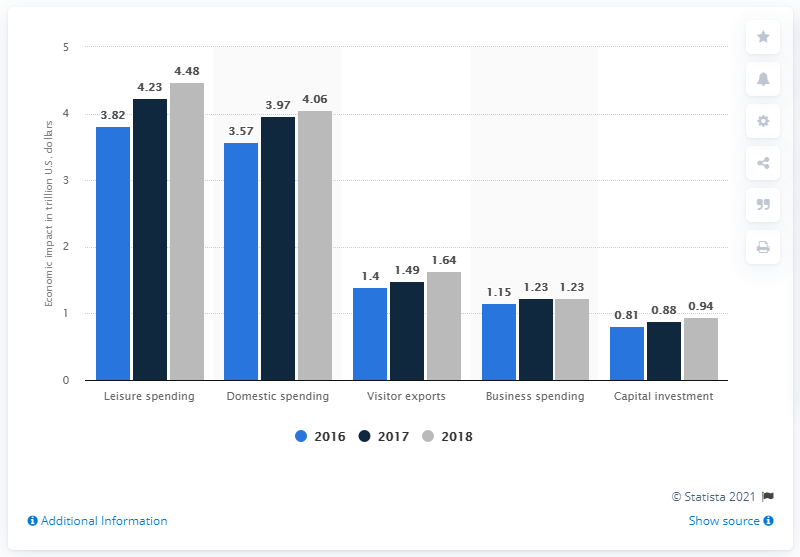Mention a couple of crucial points in this snapshot. The maximum economic impact of leisure spending and visitor exports is 2.84 trillion. In 2018, domestic travel and tourism spending contributed a significant amount to the global economy, estimated to be 4.06 trillion U.S. dollars. In 2016, the economic impact of domestic spending was estimated to be 3.57 trillion. 